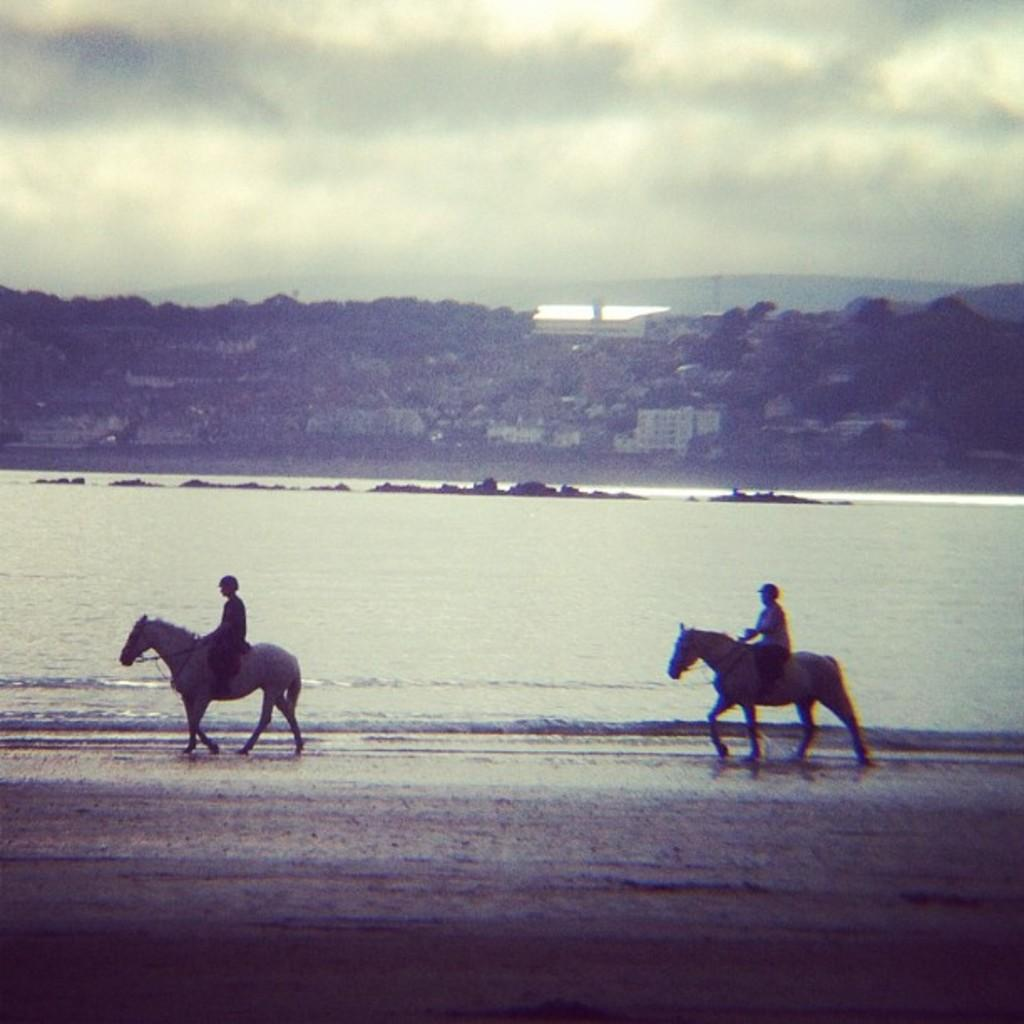How many people are in the image? There are two persons in the foreground of the image. What are the two persons doing in the image? The two persons are riding a horse. What can be seen in the background of the image? There is water, buildings, and a cloud visible in the background of the image. What type of lipstick is the horse wearing in the image? There is no lipstick or any indication of makeup on the horse in the image. 